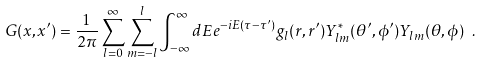<formula> <loc_0><loc_0><loc_500><loc_500>G ( x , x ^ { \prime } ) = \frac { 1 } { 2 \pi } \sum _ { l = 0 } ^ { \infty } \sum _ { m = - l } ^ { l } \int _ { - \infty } ^ { \infty } d E e ^ { - i E ( \tau - \tau ^ { \prime } ) } g _ { l } ( r , r ^ { \prime } ) Y ^ { \ast } _ { l m } ( \theta ^ { \prime } , \phi ^ { \prime } ) Y _ { l m } ( \theta , \phi ) \ .</formula> 